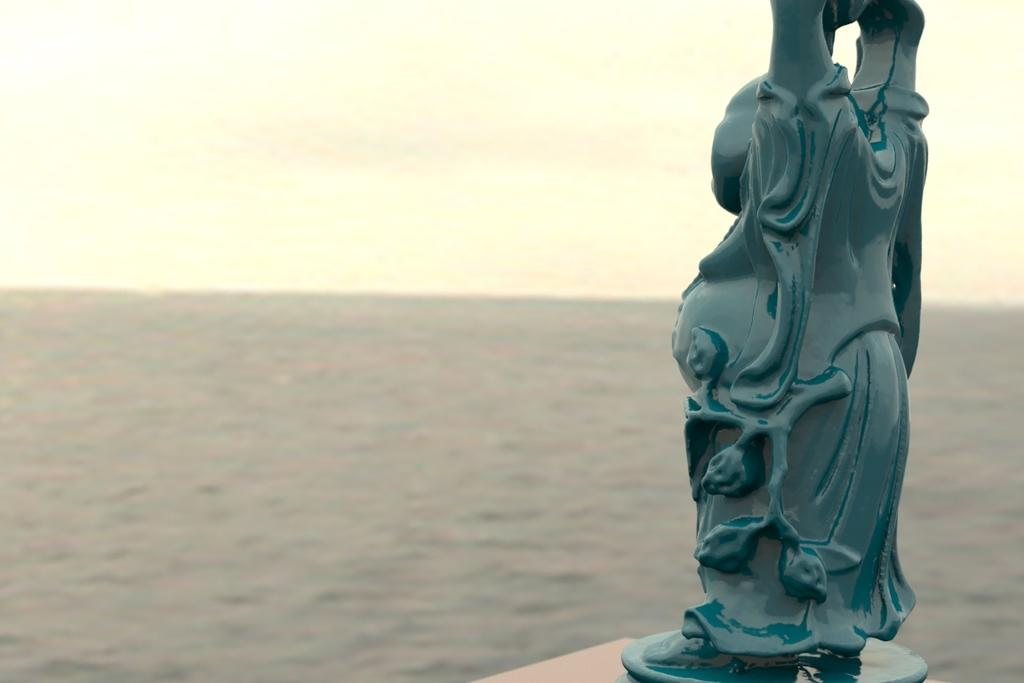What is the main subject of the image? There is a statue in the image. What else can be seen in the image besides the statue? Water is visible in the image. What is visible in the background of the image? The sky is visible in the background of the image. Can you see a snail crawling on the statue in the image? There is no snail visible on the statue in the image. Is there a lift present in the image? There is no lift present in the image. 